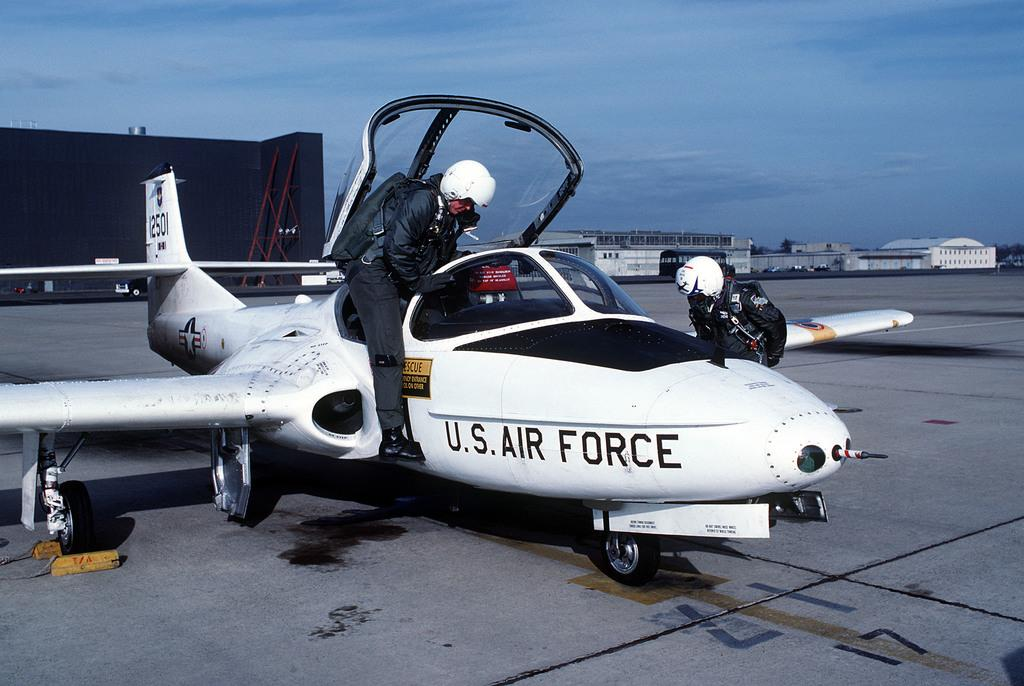<image>
Share a concise interpretation of the image provided. A man is getting into a U.S. Air Force Plane as another man leans towards it. 